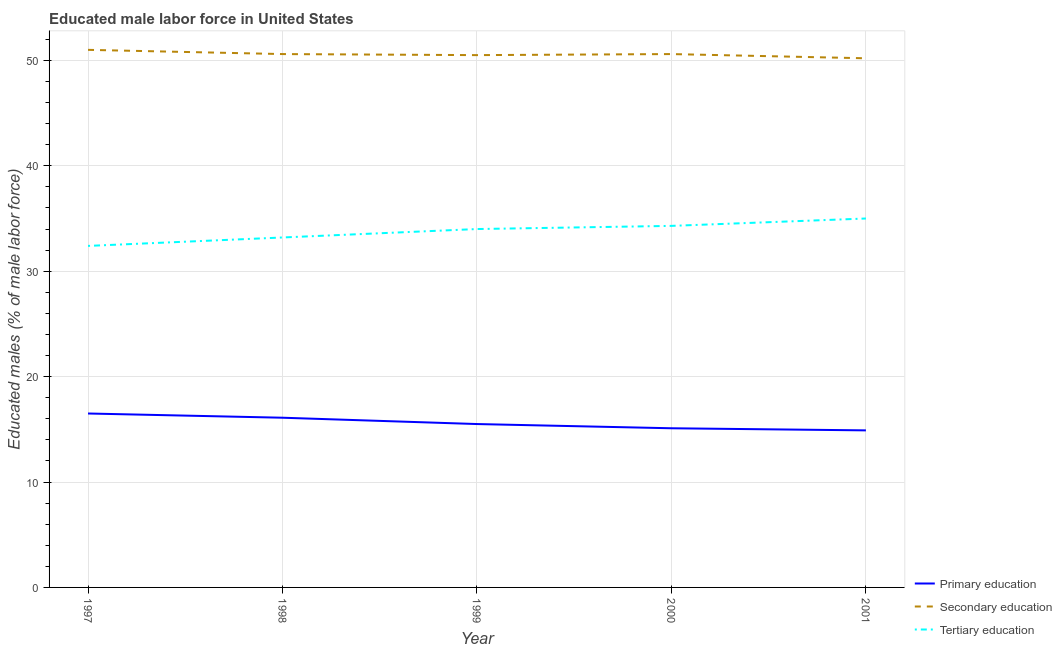Does the line corresponding to percentage of male labor force who received primary education intersect with the line corresponding to percentage of male labor force who received secondary education?
Offer a very short reply. No. What is the percentage of male labor force who received primary education in 1999?
Ensure brevity in your answer.  15.5. Across all years, what is the maximum percentage of male labor force who received primary education?
Ensure brevity in your answer.  16.5. Across all years, what is the minimum percentage of male labor force who received primary education?
Your answer should be compact. 14.9. What is the total percentage of male labor force who received secondary education in the graph?
Give a very brief answer. 252.9. What is the difference between the percentage of male labor force who received secondary education in 1997 and that in 1999?
Offer a very short reply. 0.5. What is the difference between the percentage of male labor force who received secondary education in 1999 and the percentage of male labor force who received primary education in 2000?
Your answer should be very brief. 35.4. What is the average percentage of male labor force who received tertiary education per year?
Make the answer very short. 33.78. In the year 1997, what is the difference between the percentage of male labor force who received tertiary education and percentage of male labor force who received secondary education?
Offer a terse response. -18.6. What is the ratio of the percentage of male labor force who received tertiary education in 1997 to that in 2000?
Your answer should be compact. 0.94. Is the difference between the percentage of male labor force who received tertiary education in 1997 and 1998 greater than the difference between the percentage of male labor force who received secondary education in 1997 and 1998?
Your response must be concise. No. What is the difference between the highest and the second highest percentage of male labor force who received secondary education?
Keep it short and to the point. 0.4. What is the difference between the highest and the lowest percentage of male labor force who received tertiary education?
Your answer should be compact. 2.6. Is the sum of the percentage of male labor force who received tertiary education in 1999 and 2000 greater than the maximum percentage of male labor force who received secondary education across all years?
Your response must be concise. Yes. Does the percentage of male labor force who received primary education monotonically increase over the years?
Your answer should be compact. No. Is the percentage of male labor force who received primary education strictly less than the percentage of male labor force who received tertiary education over the years?
Provide a succinct answer. Yes. How many years are there in the graph?
Offer a very short reply. 5. Does the graph contain grids?
Your response must be concise. Yes. How many legend labels are there?
Ensure brevity in your answer.  3. What is the title of the graph?
Your response must be concise. Educated male labor force in United States. Does "Agricultural raw materials" appear as one of the legend labels in the graph?
Give a very brief answer. No. What is the label or title of the X-axis?
Your answer should be very brief. Year. What is the label or title of the Y-axis?
Your answer should be very brief. Educated males (% of male labor force). What is the Educated males (% of male labor force) in Tertiary education in 1997?
Your answer should be very brief. 32.4. What is the Educated males (% of male labor force) of Primary education in 1998?
Ensure brevity in your answer.  16.1. What is the Educated males (% of male labor force) in Secondary education in 1998?
Give a very brief answer. 50.6. What is the Educated males (% of male labor force) in Tertiary education in 1998?
Keep it short and to the point. 33.2. What is the Educated males (% of male labor force) of Secondary education in 1999?
Provide a short and direct response. 50.5. What is the Educated males (% of male labor force) of Primary education in 2000?
Your answer should be compact. 15.1. What is the Educated males (% of male labor force) of Secondary education in 2000?
Keep it short and to the point. 50.6. What is the Educated males (% of male labor force) of Tertiary education in 2000?
Keep it short and to the point. 34.3. What is the Educated males (% of male labor force) of Primary education in 2001?
Your answer should be compact. 14.9. What is the Educated males (% of male labor force) in Secondary education in 2001?
Keep it short and to the point. 50.2. Across all years, what is the maximum Educated males (% of male labor force) of Primary education?
Your answer should be very brief. 16.5. Across all years, what is the maximum Educated males (% of male labor force) in Secondary education?
Ensure brevity in your answer.  51. Across all years, what is the minimum Educated males (% of male labor force) in Primary education?
Keep it short and to the point. 14.9. Across all years, what is the minimum Educated males (% of male labor force) in Secondary education?
Ensure brevity in your answer.  50.2. Across all years, what is the minimum Educated males (% of male labor force) in Tertiary education?
Offer a very short reply. 32.4. What is the total Educated males (% of male labor force) in Primary education in the graph?
Your answer should be compact. 78.1. What is the total Educated males (% of male labor force) of Secondary education in the graph?
Offer a very short reply. 252.9. What is the total Educated males (% of male labor force) of Tertiary education in the graph?
Provide a succinct answer. 168.9. What is the difference between the Educated males (% of male labor force) of Secondary education in 1997 and that in 1998?
Your answer should be compact. 0.4. What is the difference between the Educated males (% of male labor force) in Tertiary education in 1997 and that in 1999?
Your answer should be compact. -1.6. What is the difference between the Educated males (% of male labor force) of Primary education in 1997 and that in 2001?
Ensure brevity in your answer.  1.6. What is the difference between the Educated males (% of male labor force) in Secondary education in 1997 and that in 2001?
Provide a succinct answer. 0.8. What is the difference between the Educated males (% of male labor force) of Secondary education in 1998 and that in 1999?
Provide a succinct answer. 0.1. What is the difference between the Educated males (% of male labor force) of Tertiary education in 1998 and that in 1999?
Provide a succinct answer. -0.8. What is the difference between the Educated males (% of male labor force) in Primary education in 1998 and that in 2000?
Your answer should be compact. 1. What is the difference between the Educated males (% of male labor force) of Tertiary education in 1998 and that in 2000?
Your answer should be compact. -1.1. What is the difference between the Educated males (% of male labor force) in Primary education in 1999 and that in 2000?
Ensure brevity in your answer.  0.4. What is the difference between the Educated males (% of male labor force) of Secondary education in 1999 and that in 2000?
Ensure brevity in your answer.  -0.1. What is the difference between the Educated males (% of male labor force) of Primary education in 1999 and that in 2001?
Your answer should be compact. 0.6. What is the difference between the Educated males (% of male labor force) of Secondary education in 1999 and that in 2001?
Make the answer very short. 0.3. What is the difference between the Educated males (% of male labor force) in Tertiary education in 1999 and that in 2001?
Make the answer very short. -1. What is the difference between the Educated males (% of male labor force) of Secondary education in 2000 and that in 2001?
Ensure brevity in your answer.  0.4. What is the difference between the Educated males (% of male labor force) in Tertiary education in 2000 and that in 2001?
Your response must be concise. -0.7. What is the difference between the Educated males (% of male labor force) of Primary education in 1997 and the Educated males (% of male labor force) of Secondary education in 1998?
Offer a terse response. -34.1. What is the difference between the Educated males (% of male labor force) in Primary education in 1997 and the Educated males (% of male labor force) in Tertiary education in 1998?
Your answer should be very brief. -16.7. What is the difference between the Educated males (% of male labor force) in Secondary education in 1997 and the Educated males (% of male labor force) in Tertiary education in 1998?
Give a very brief answer. 17.8. What is the difference between the Educated males (% of male labor force) in Primary education in 1997 and the Educated males (% of male labor force) in Secondary education in 1999?
Provide a succinct answer. -34. What is the difference between the Educated males (% of male labor force) in Primary education in 1997 and the Educated males (% of male labor force) in Tertiary education in 1999?
Give a very brief answer. -17.5. What is the difference between the Educated males (% of male labor force) in Primary education in 1997 and the Educated males (% of male labor force) in Secondary education in 2000?
Your response must be concise. -34.1. What is the difference between the Educated males (% of male labor force) of Primary education in 1997 and the Educated males (% of male labor force) of Tertiary education in 2000?
Offer a terse response. -17.8. What is the difference between the Educated males (% of male labor force) in Primary education in 1997 and the Educated males (% of male labor force) in Secondary education in 2001?
Offer a very short reply. -33.7. What is the difference between the Educated males (% of male labor force) of Primary education in 1997 and the Educated males (% of male labor force) of Tertiary education in 2001?
Ensure brevity in your answer.  -18.5. What is the difference between the Educated males (% of male labor force) in Primary education in 1998 and the Educated males (% of male labor force) in Secondary education in 1999?
Offer a very short reply. -34.4. What is the difference between the Educated males (% of male labor force) in Primary education in 1998 and the Educated males (% of male labor force) in Tertiary education in 1999?
Offer a terse response. -17.9. What is the difference between the Educated males (% of male labor force) in Primary education in 1998 and the Educated males (% of male labor force) in Secondary education in 2000?
Provide a succinct answer. -34.5. What is the difference between the Educated males (% of male labor force) in Primary education in 1998 and the Educated males (% of male labor force) in Tertiary education in 2000?
Your answer should be very brief. -18.2. What is the difference between the Educated males (% of male labor force) of Secondary education in 1998 and the Educated males (% of male labor force) of Tertiary education in 2000?
Make the answer very short. 16.3. What is the difference between the Educated males (% of male labor force) of Primary education in 1998 and the Educated males (% of male labor force) of Secondary education in 2001?
Make the answer very short. -34.1. What is the difference between the Educated males (% of male labor force) in Primary education in 1998 and the Educated males (% of male labor force) in Tertiary education in 2001?
Ensure brevity in your answer.  -18.9. What is the difference between the Educated males (% of male labor force) of Primary education in 1999 and the Educated males (% of male labor force) of Secondary education in 2000?
Keep it short and to the point. -35.1. What is the difference between the Educated males (% of male labor force) of Primary education in 1999 and the Educated males (% of male labor force) of Tertiary education in 2000?
Ensure brevity in your answer.  -18.8. What is the difference between the Educated males (% of male labor force) of Secondary education in 1999 and the Educated males (% of male labor force) of Tertiary education in 2000?
Make the answer very short. 16.2. What is the difference between the Educated males (% of male labor force) of Primary education in 1999 and the Educated males (% of male labor force) of Secondary education in 2001?
Offer a terse response. -34.7. What is the difference between the Educated males (% of male labor force) in Primary education in 1999 and the Educated males (% of male labor force) in Tertiary education in 2001?
Provide a succinct answer. -19.5. What is the difference between the Educated males (% of male labor force) in Primary education in 2000 and the Educated males (% of male labor force) in Secondary education in 2001?
Offer a terse response. -35.1. What is the difference between the Educated males (% of male labor force) in Primary education in 2000 and the Educated males (% of male labor force) in Tertiary education in 2001?
Ensure brevity in your answer.  -19.9. What is the average Educated males (% of male labor force) in Primary education per year?
Your answer should be compact. 15.62. What is the average Educated males (% of male labor force) in Secondary education per year?
Ensure brevity in your answer.  50.58. What is the average Educated males (% of male labor force) in Tertiary education per year?
Your response must be concise. 33.78. In the year 1997, what is the difference between the Educated males (% of male labor force) of Primary education and Educated males (% of male labor force) of Secondary education?
Your answer should be compact. -34.5. In the year 1997, what is the difference between the Educated males (% of male labor force) in Primary education and Educated males (% of male labor force) in Tertiary education?
Provide a short and direct response. -15.9. In the year 1997, what is the difference between the Educated males (% of male labor force) of Secondary education and Educated males (% of male labor force) of Tertiary education?
Your answer should be compact. 18.6. In the year 1998, what is the difference between the Educated males (% of male labor force) in Primary education and Educated males (% of male labor force) in Secondary education?
Your response must be concise. -34.5. In the year 1998, what is the difference between the Educated males (% of male labor force) of Primary education and Educated males (% of male labor force) of Tertiary education?
Your answer should be compact. -17.1. In the year 1998, what is the difference between the Educated males (% of male labor force) in Secondary education and Educated males (% of male labor force) in Tertiary education?
Offer a very short reply. 17.4. In the year 1999, what is the difference between the Educated males (% of male labor force) of Primary education and Educated males (% of male labor force) of Secondary education?
Provide a succinct answer. -35. In the year 1999, what is the difference between the Educated males (% of male labor force) in Primary education and Educated males (% of male labor force) in Tertiary education?
Offer a terse response. -18.5. In the year 2000, what is the difference between the Educated males (% of male labor force) in Primary education and Educated males (% of male labor force) in Secondary education?
Keep it short and to the point. -35.5. In the year 2000, what is the difference between the Educated males (% of male labor force) of Primary education and Educated males (% of male labor force) of Tertiary education?
Your response must be concise. -19.2. In the year 2001, what is the difference between the Educated males (% of male labor force) of Primary education and Educated males (% of male labor force) of Secondary education?
Make the answer very short. -35.3. In the year 2001, what is the difference between the Educated males (% of male labor force) in Primary education and Educated males (% of male labor force) in Tertiary education?
Offer a very short reply. -20.1. What is the ratio of the Educated males (% of male labor force) of Primary education in 1997 to that in 1998?
Your answer should be compact. 1.02. What is the ratio of the Educated males (% of male labor force) in Secondary education in 1997 to that in 1998?
Provide a short and direct response. 1.01. What is the ratio of the Educated males (% of male labor force) of Tertiary education in 1997 to that in 1998?
Ensure brevity in your answer.  0.98. What is the ratio of the Educated males (% of male labor force) in Primary education in 1997 to that in 1999?
Ensure brevity in your answer.  1.06. What is the ratio of the Educated males (% of male labor force) of Secondary education in 1997 to that in 1999?
Your response must be concise. 1.01. What is the ratio of the Educated males (% of male labor force) of Tertiary education in 1997 to that in 1999?
Your answer should be very brief. 0.95. What is the ratio of the Educated males (% of male labor force) in Primary education in 1997 to that in 2000?
Make the answer very short. 1.09. What is the ratio of the Educated males (% of male labor force) of Secondary education in 1997 to that in 2000?
Make the answer very short. 1.01. What is the ratio of the Educated males (% of male labor force) of Tertiary education in 1997 to that in 2000?
Make the answer very short. 0.94. What is the ratio of the Educated males (% of male labor force) of Primary education in 1997 to that in 2001?
Give a very brief answer. 1.11. What is the ratio of the Educated males (% of male labor force) of Secondary education in 1997 to that in 2001?
Your response must be concise. 1.02. What is the ratio of the Educated males (% of male labor force) of Tertiary education in 1997 to that in 2001?
Your response must be concise. 0.93. What is the ratio of the Educated males (% of male labor force) in Primary education in 1998 to that in 1999?
Give a very brief answer. 1.04. What is the ratio of the Educated males (% of male labor force) of Secondary education in 1998 to that in 1999?
Offer a very short reply. 1. What is the ratio of the Educated males (% of male labor force) of Tertiary education in 1998 to that in 1999?
Give a very brief answer. 0.98. What is the ratio of the Educated males (% of male labor force) of Primary education in 1998 to that in 2000?
Your response must be concise. 1.07. What is the ratio of the Educated males (% of male labor force) of Tertiary education in 1998 to that in 2000?
Keep it short and to the point. 0.97. What is the ratio of the Educated males (% of male labor force) in Primary education in 1998 to that in 2001?
Ensure brevity in your answer.  1.08. What is the ratio of the Educated males (% of male labor force) in Secondary education in 1998 to that in 2001?
Offer a very short reply. 1.01. What is the ratio of the Educated males (% of male labor force) of Tertiary education in 1998 to that in 2001?
Provide a short and direct response. 0.95. What is the ratio of the Educated males (% of male labor force) in Primary education in 1999 to that in 2000?
Your answer should be very brief. 1.03. What is the ratio of the Educated males (% of male labor force) in Secondary education in 1999 to that in 2000?
Offer a terse response. 1. What is the ratio of the Educated males (% of male labor force) in Tertiary education in 1999 to that in 2000?
Your response must be concise. 0.99. What is the ratio of the Educated males (% of male labor force) of Primary education in 1999 to that in 2001?
Keep it short and to the point. 1.04. What is the ratio of the Educated males (% of male labor force) of Tertiary education in 1999 to that in 2001?
Your response must be concise. 0.97. What is the ratio of the Educated males (% of male labor force) in Primary education in 2000 to that in 2001?
Your answer should be compact. 1.01. What is the ratio of the Educated males (% of male labor force) in Secondary education in 2000 to that in 2001?
Your answer should be very brief. 1.01. What is the difference between the highest and the second highest Educated males (% of male labor force) in Tertiary education?
Offer a terse response. 0.7. 